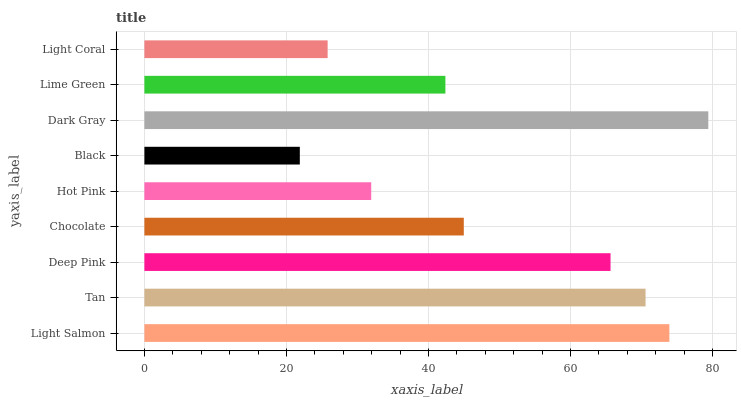Is Black the minimum?
Answer yes or no. Yes. Is Dark Gray the maximum?
Answer yes or no. Yes. Is Tan the minimum?
Answer yes or no. No. Is Tan the maximum?
Answer yes or no. No. Is Light Salmon greater than Tan?
Answer yes or no. Yes. Is Tan less than Light Salmon?
Answer yes or no. Yes. Is Tan greater than Light Salmon?
Answer yes or no. No. Is Light Salmon less than Tan?
Answer yes or no. No. Is Chocolate the high median?
Answer yes or no. Yes. Is Chocolate the low median?
Answer yes or no. Yes. Is Light Salmon the high median?
Answer yes or no. No. Is Light Salmon the low median?
Answer yes or no. No. 